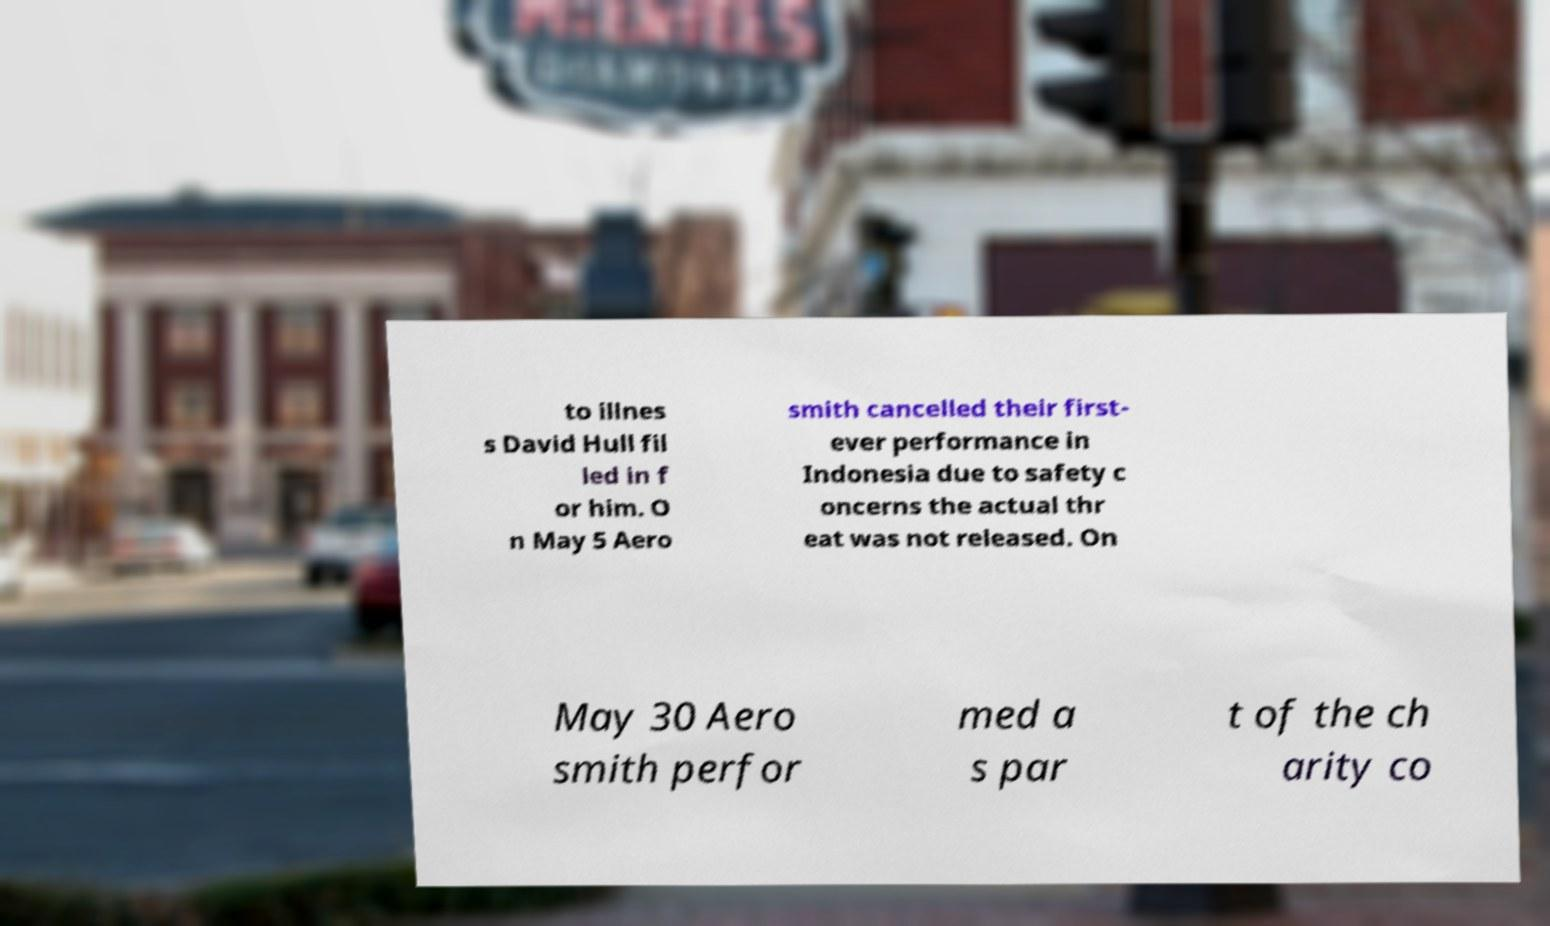Could you extract and type out the text from this image? to illnes s David Hull fil led in f or him. O n May 5 Aero smith cancelled their first- ever performance in Indonesia due to safety c oncerns the actual thr eat was not released. On May 30 Aero smith perfor med a s par t of the ch arity co 